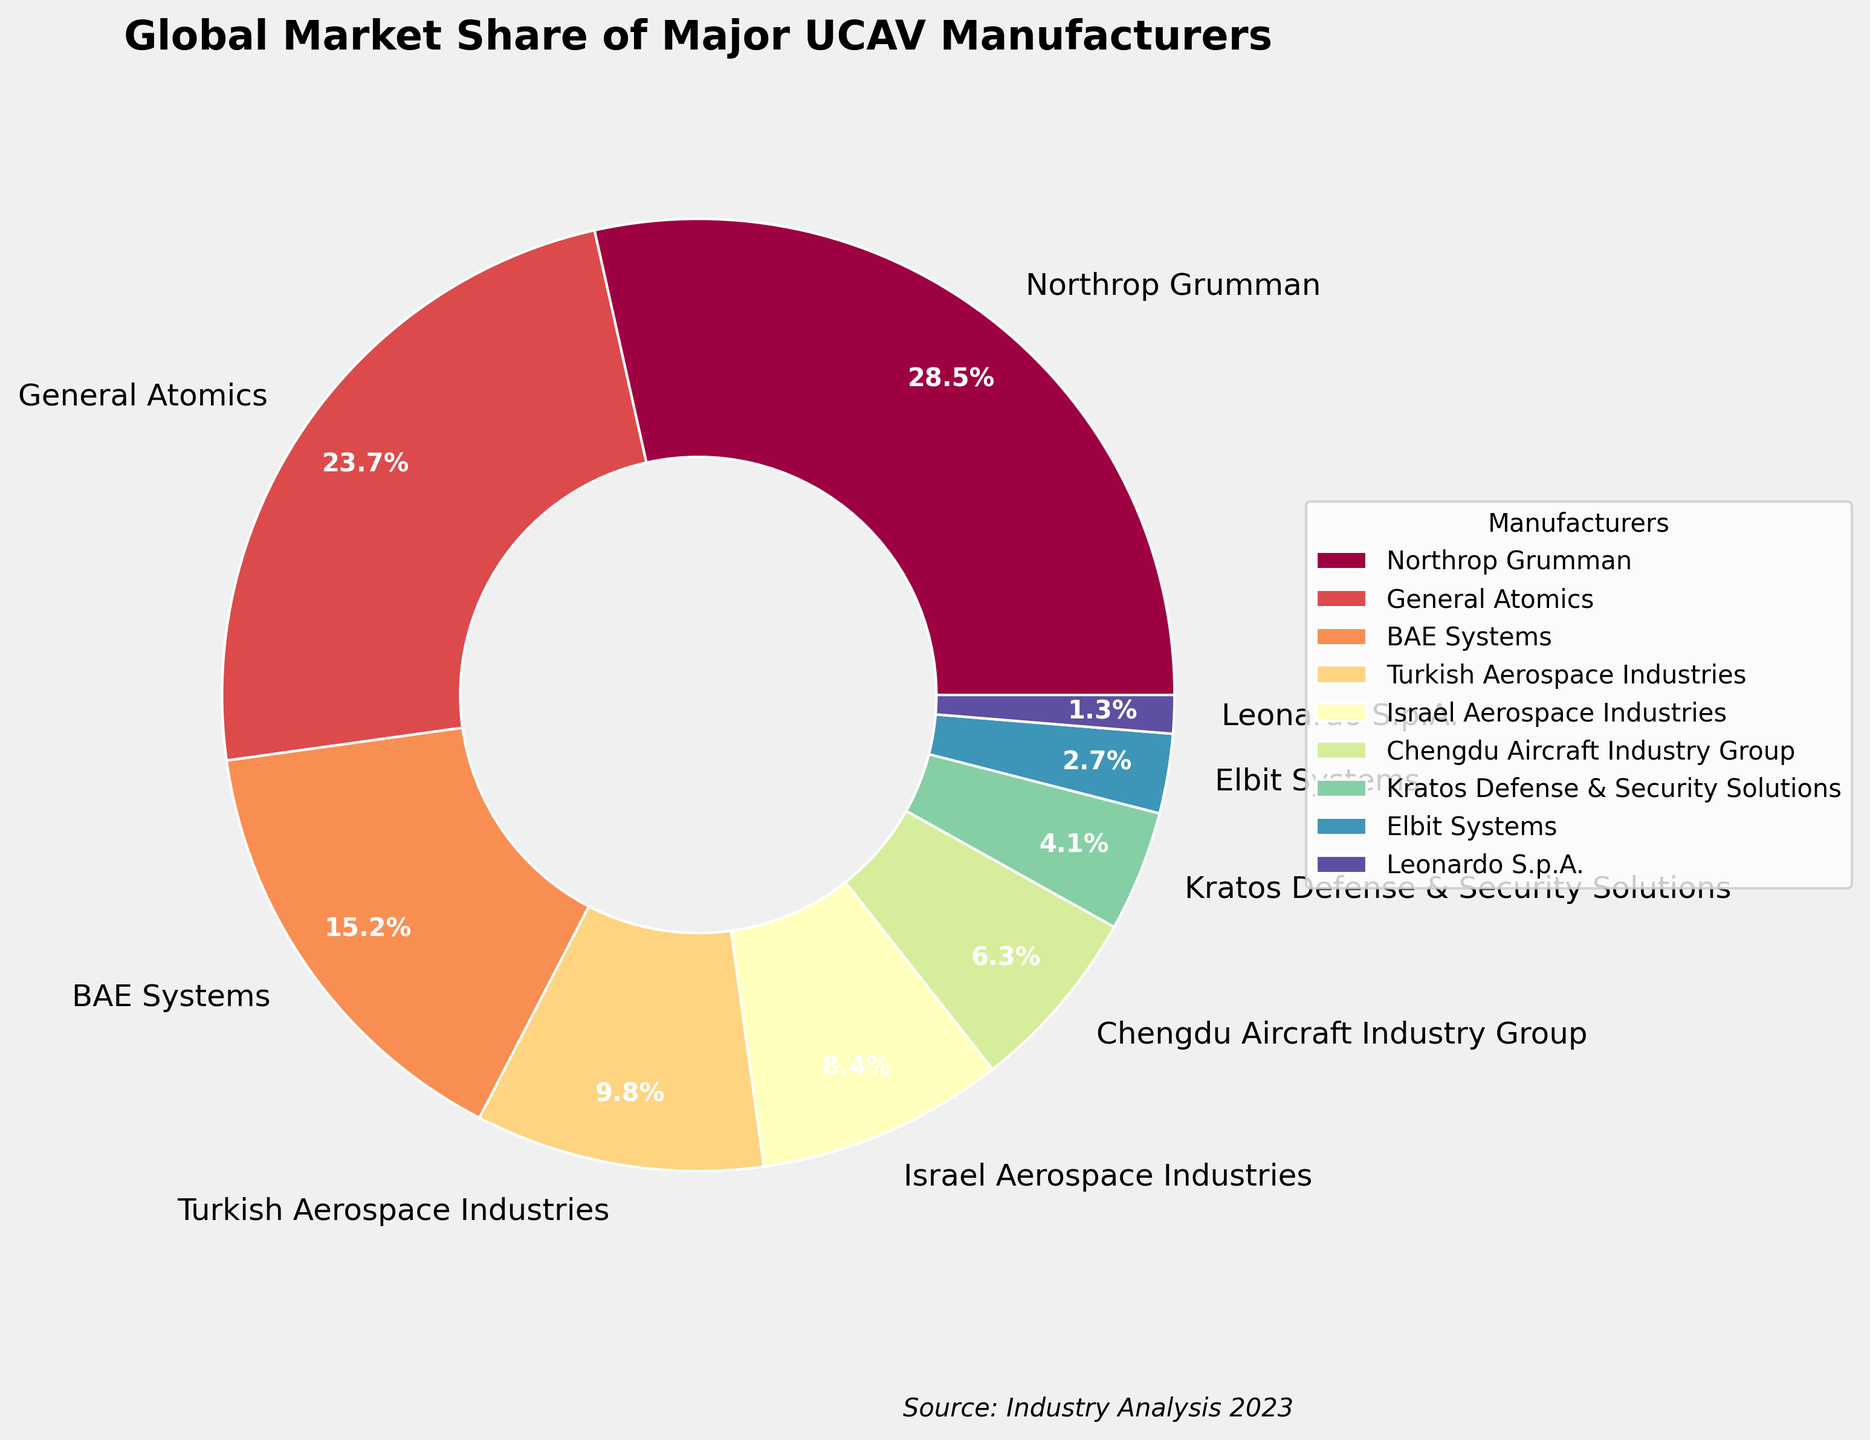What's the market share of the top manufacturer? The figure shows the percentage of market share for each manufacturer. According to the chart, Northrop Grumman is the top manufacturer with a market share of 28.5%.
Answer: 28.5% Which manufacturers have a market share greater than 10%? To find this, we look for the manufacturers whose pie chart segments are labeled with a number greater than 10%. These are Northrop Grumman (28.5%), General Atomics (23.7%), and BAE Systems (15.2%).
Answer: Northrop Grumman, General Atomics, BAE Systems What's the total market share of manufacturers with less than 5% market share each? We add the market shares of manufacturers with less than 5% individually, which are Kratos Defense & Security Solutions, Elbit Systems, and Leonardo S.p.A. Their market shares are 4.1%, 2.7%, and 1.3% respectively. Summing these up: 4.1 + 2.7 + 1.3 = 8.1%.
Answer: 8.1% Which manufacturer has the second-highest market share? By looking at the market share percentages, the second-highest value after Northrop Grumman's 28.5% is General Atomics with 23.7%.
Answer: General Atomics What's the market share difference between the highest and the lowest manufacturer? The highest market share is 28.5% (Northrop Grumman) and the lowest is 1.3% (Leonardo S.p.A.). We calculate the difference: 28.5 - 1.3 = 27.2%.
Answer: 27.2% Compare the combined market share of BAE Systems and Turkish Aerospace Industries to Northrop Grumman's market share. Which is higher? BAE Systems has a market share of 15.2% and Turkish Aerospace Industries has 9.8%. Combined, they have 15.2 + 9.8 = 25%. Northrop Grumman alone has 28.5%, which is higher.
Answer: Northrop Grumman What proportion of the market share is held by Israeli companies (Israel Aerospace Industries and Elbit Systems)? Summing the market shares of Israel Aerospace Industries (8.4%) and Elbit Systems (2.7%), we get 8.4 + 2.7 = 11.1%.
Answer: 11.1% Is there a significant visual difference in the pie chart between the market shares of Chengdu Aircraft Industry Group and Kratos Defense & Security Solutions? Chengdu Aircraft Industry Group has 6.3% and Kratos Defense & Security Solutions has 4.1%. The visual difference in their pie chart sections can be observed, with Chengdu's section being slightly larger.
Answer: Yes Calculate the average market share of the manufacturers listed. To find the average, sum all the market shares and divide by the number of manufacturers. The sum is 28.5 + 23.7 + 15.2 + 9.8 + 8.4 + 6.3 + 4.1 + 2.7 + 1.3 = 100%. Since there are 9 manufacturers, the average market share is 100 / 9 ≈ 11.11%.
Answer: 11.11% What percentage of the market share is controlled by non-US companies? (List: BAE Systems, Turkish Aerospace Industries, Israel Aerospace Industries, Chengdu Aircraft Industry Group, Kratos Defense & Security Solutions, Elbit Systems, Leonardo S.p.A.) Adding the market shares of non-US manufacturers: BAE Systems (15.2%), Turkish Aerospace Industries (9.8%), Israel Aerospace Industries (8.4%), Chengdu Aircraft Industry Group (6.3%), Elbit Systems (2.7%), Leonardo S.p.A. (1.3%) gives 15.2 + 9.8 + 8.4 + 6.3 + 2.7 + 1.3 = 43.7%.
Answer: 43.7% 